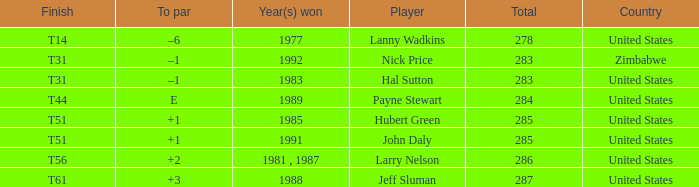What is Country, when Total is greater than 283, and when Year(s) Won is "1989"? United States. 